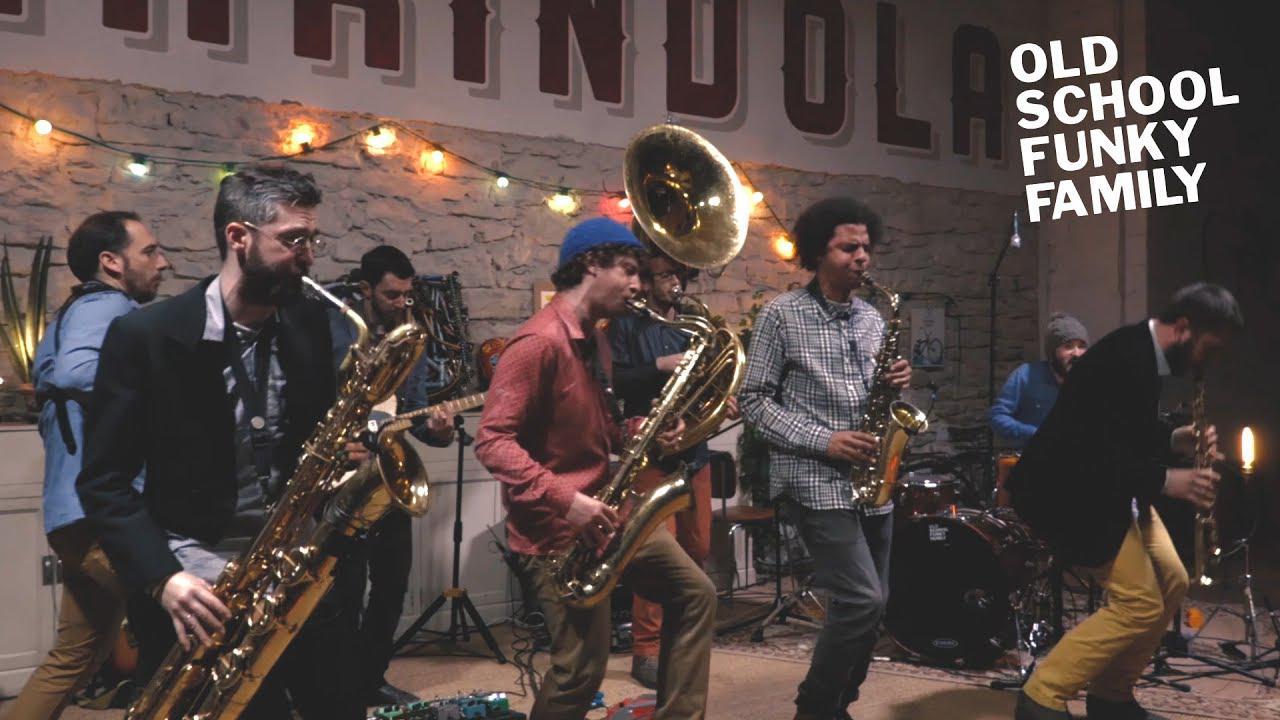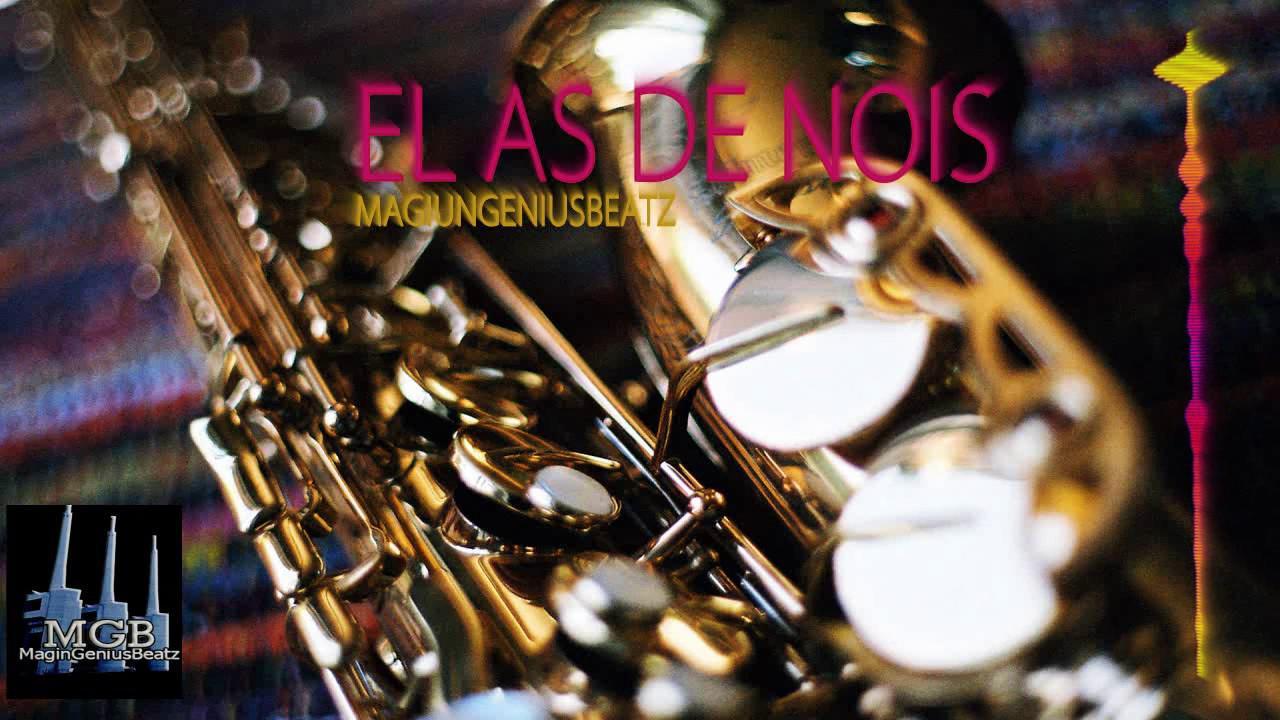The first image is the image on the left, the second image is the image on the right. Considering the images on both sides, is "Every single person's elbow is clothed." valid? Answer yes or no. Yes. The first image is the image on the left, the second image is the image on the right. Examine the images to the left and right. Is the description "One image shows a saxophone held by a dark-skinned man in a suit, and the other image shows someone with long hair holding a saxophone in front of a flight of stairs." accurate? Answer yes or no. No. 